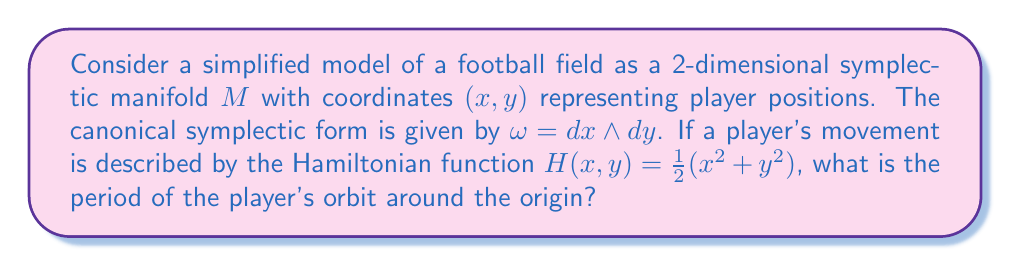Give your solution to this math problem. To solve this problem, we'll follow these steps:

1) In a symplectic manifold with coordinates $(x, y)$ and symplectic form $\omega = dx \wedge dy$, Hamilton's equations are:

   $$\frac{dx}{dt} = \frac{\partial H}{\partial y}, \quad \frac{dy}{dt} = -\frac{\partial H}{\partial x}$$

2) For the given Hamiltonian $H(x,y) = \frac{1}{2}(x^2 + y^2)$, we have:

   $$\frac{\partial H}{\partial x} = x, \quad \frac{\partial H}{\partial y} = y$$

3) Substituting into Hamilton's equations:

   $$\frac{dx}{dt} = y, \quad \frac{dy}{dt} = -x$$

4) These equations describe simple harmonic motion. The general solution is:

   $$x(t) = A\cos(t + \phi), \quad y(t) = A\sin(t + \phi)$$

   where $A$ is the amplitude and $\phi$ is a phase constant.

5) The period $T$ of this motion is the time it takes to complete one full revolution. For simple harmonic motion with angular frequency $\omega = 1$ (as in this case), the period is given by:

   $$T = \frac{2\pi}{\omega} = 2\pi$$

This result is independent of the amplitude $A$, meaning all orbits have the same period, a characteristic property of the harmonic oscillator.
Answer: The period of the player's orbit is $2\pi$. 